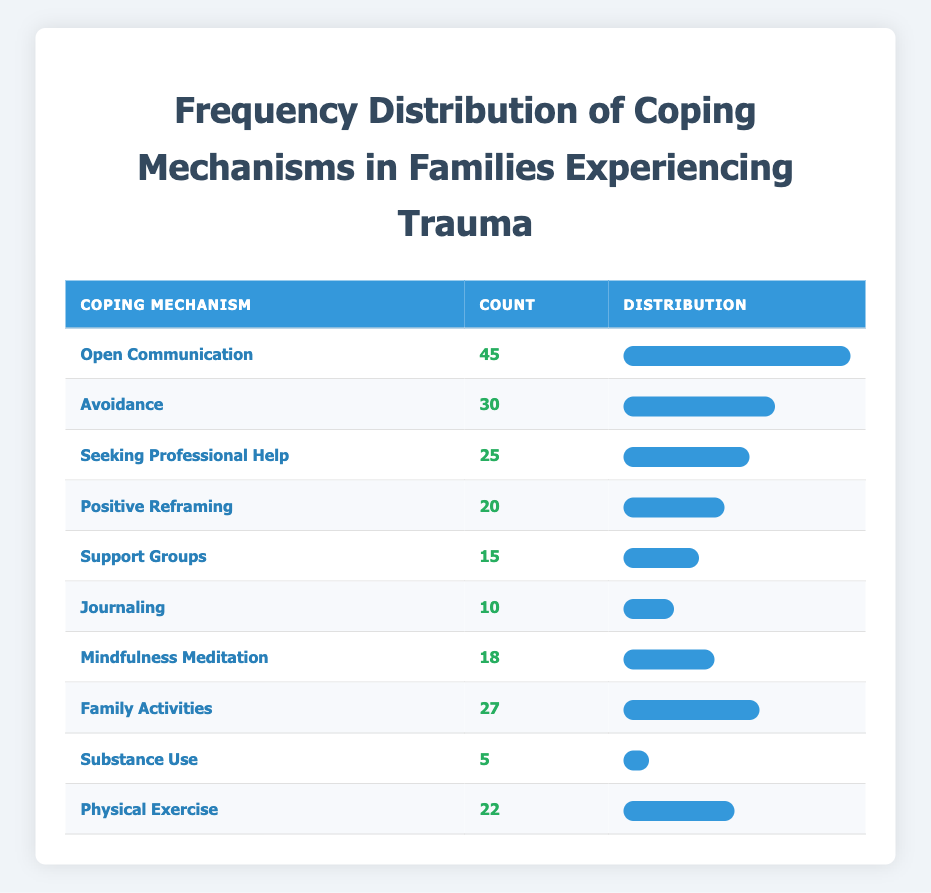What is the most common coping mechanism among families experiencing trauma? The table displays various coping mechanisms along with their counts. The highest count is 45 for "Open Communication," indicating that it is the most common coping mechanism.
Answer: Open Communication How many families use "Substance Use" as a coping mechanism? Referring to the table, the count for "Substance Use" is 5, indicating that 5 families use this mechanism.
Answer: 5 What is the total count of families using "Positive Reframing" and "Family Activities"? The count for "Positive Reframing" is 20 and for "Family Activities," it is 27. Summing these counts gives 20 + 27 = 47.
Answer: 47 Is "Journaling" a more commonly used coping mechanism than "Support Groups"? The table shows that "Journaling" has a count of 10 and "Support Groups" has a count of 15. Since 10 is less than 15, this statement is false.
Answer: No What percentage of families use "Mindfulness Meditation" compared to those using "Open Communication"? "Mindfulness Meditation" has a count of 18, and "Open Communication" has a count of 45. To find the percentage, divide 18 by 45 and then multiply by 100, which gives approximately 40%.
Answer: 40% Which coping mechanism is used by the least number of families? The table indicates that "Substance Use" has the lowest count at 5, making it the least used coping mechanism.
Answer: Substance Use What is the average count of families using all listed coping mechanisms? To find the average, sum all counts: 45 + 30 + 25 + 20 + 15 + 10 + 18 + 27 + 5 + 22 =  217. There are 10 mechanisms, so the average is 217 / 10 = 21.7.
Answer: 21.7 Are there more families practicing "Physical Exercise" than "Mindfulness Meditation"? The count for "Physical Exercise" is 22, while for "Mindfulness Meditation," it is 18. Since 22 is greater than 18, this statement is true.
Answer: Yes What is the difference in count between the most popular and the least popular coping mechanisms? The most popular mechanism is "Open Communication" with a count of 45, and the least popular is "Substance Use" with a count of 5. The difference is 45 - 5 = 40.
Answer: 40 